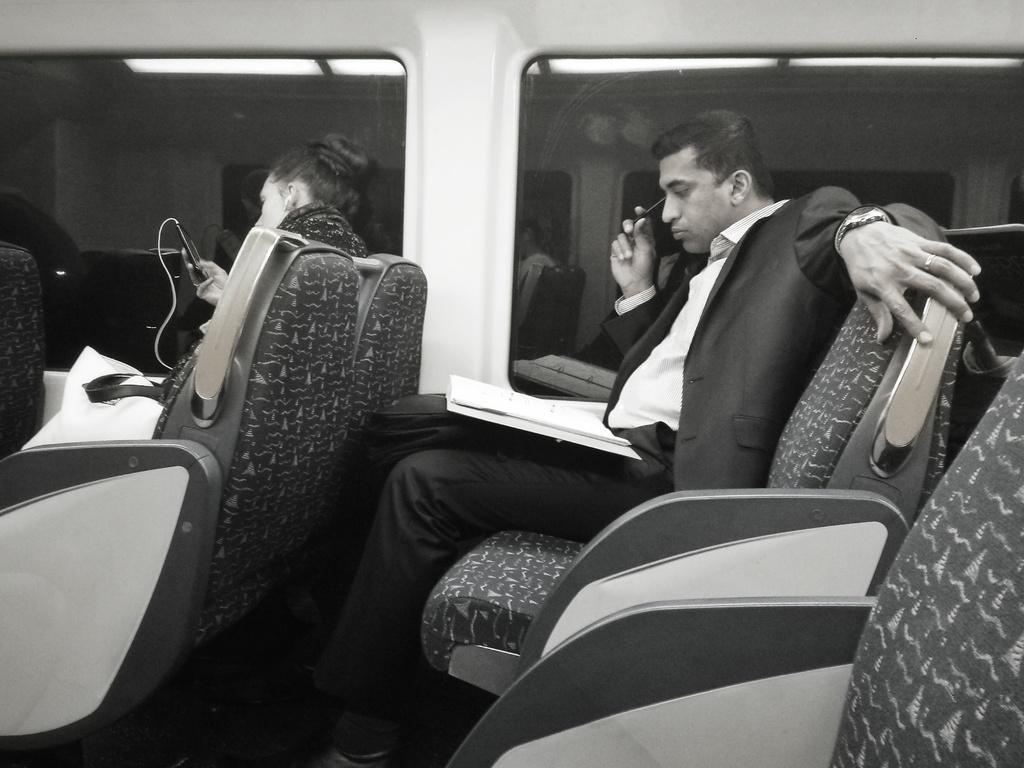How would you summarize this image in a sentence or two? In this picture we can see two people are sitting on the seats. Here we can see a bookbag, and a mobile. In the background we can see glass and lights. 